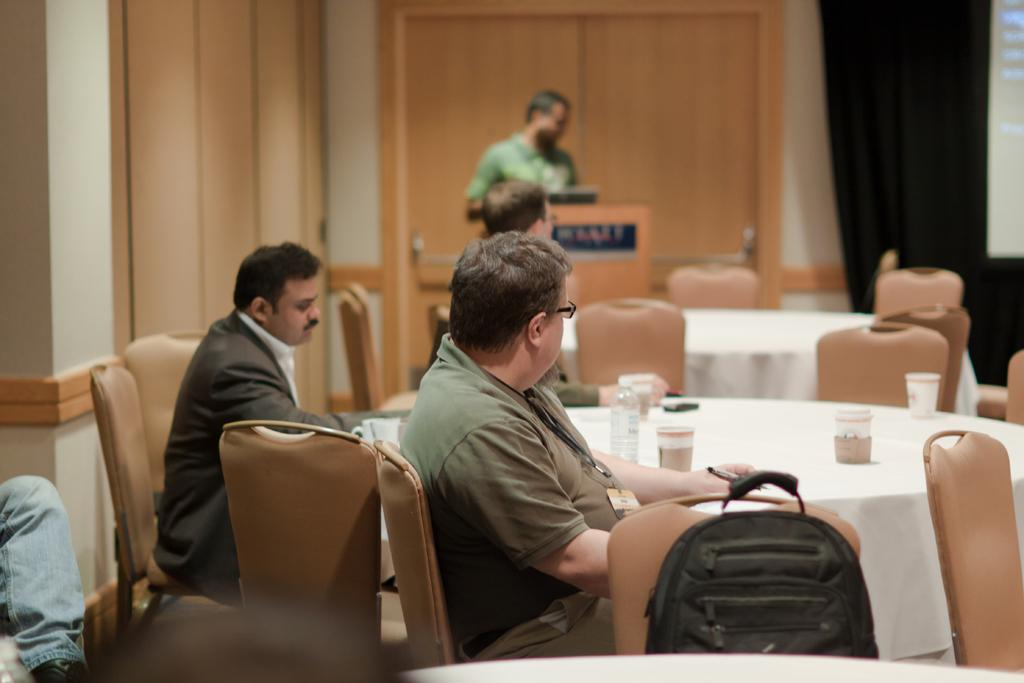How many people are in the image? There is a group of people in the image. What are the people doing in the image? Some of the people are sitting, while one is standing. What is in front of the group? There is a table in front of the group. Is there any object placed on the chairs? Yes, a bag is kept on one of the chairs. What type of sheet is being used as apparel by the people in the image? There is no sheet being used as apparel by the people in the image. How many weeks have passed since the event depicted in the image? The image does not provide any information about the time or duration of the event. 